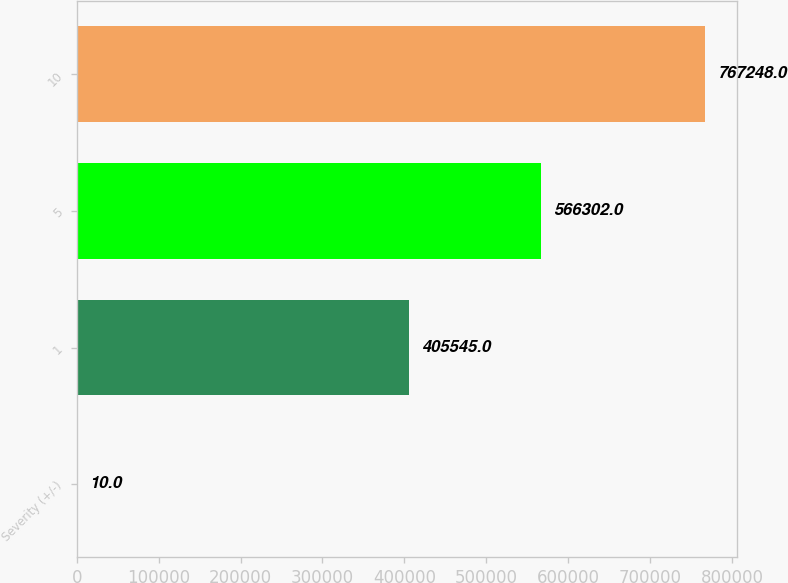<chart> <loc_0><loc_0><loc_500><loc_500><bar_chart><fcel>Severity (+/-)<fcel>1<fcel>5<fcel>10<nl><fcel>10<fcel>405545<fcel>566302<fcel>767248<nl></chart> 